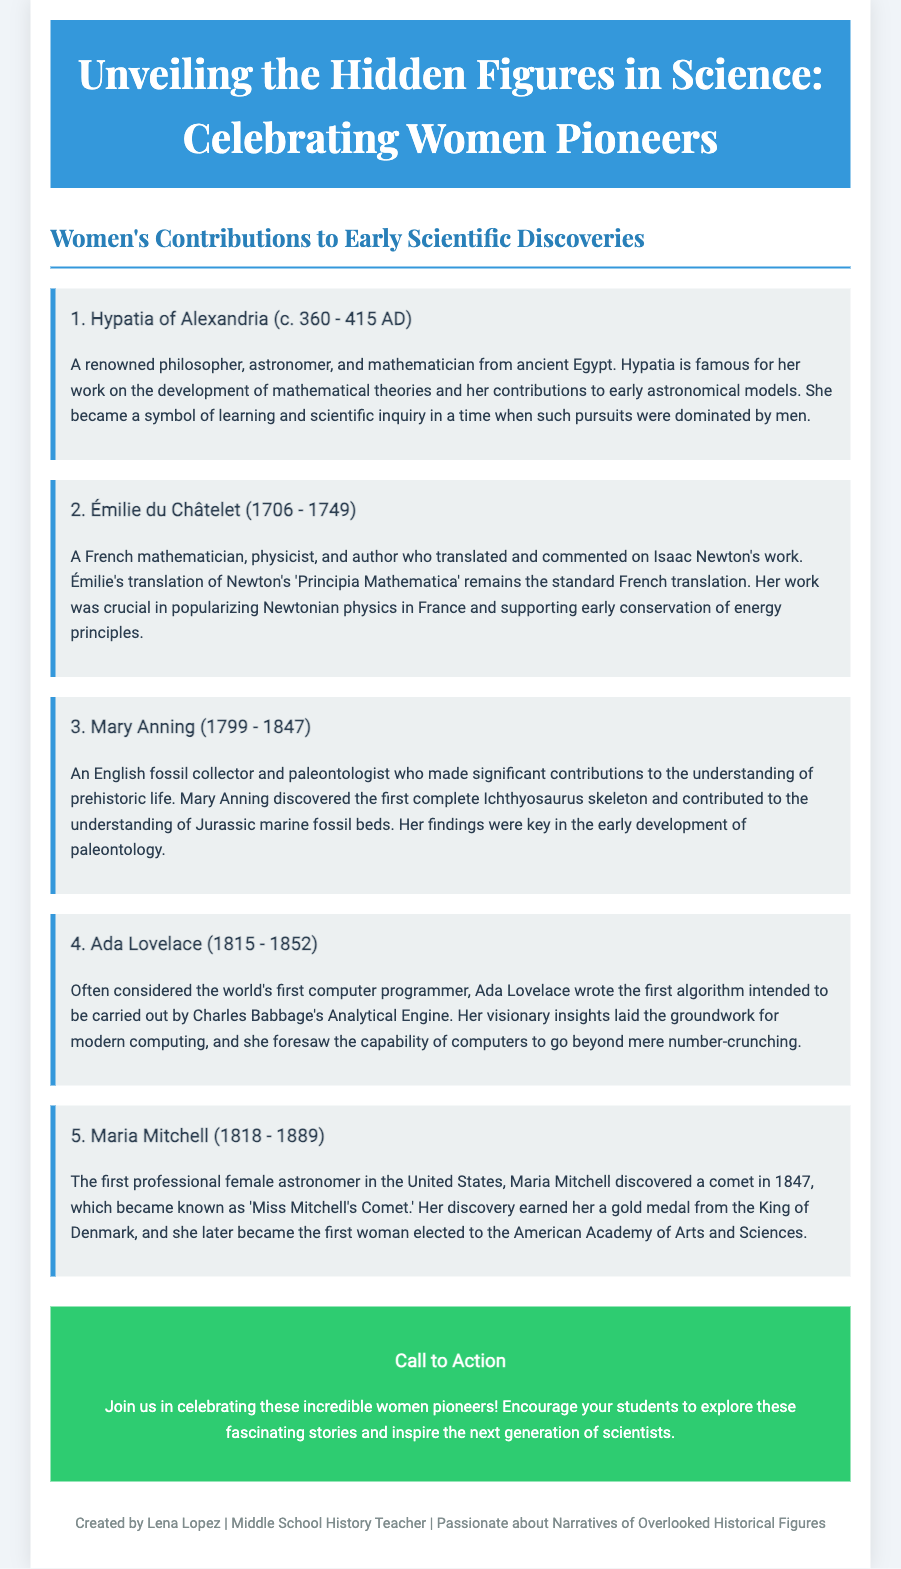What are the names of the first five female scientists featured? The document includes Hypatia of Alexandria, Émilie du Châtelet, Mary Anning, Ada Lovelace, and Maria Mitchell as the first five female scientists.
Answer: Hypatia of Alexandria, Émilie du Châtelet, Mary Anning, Ada Lovelace, Maria Mitchell What century was Hypatia of Alexandria active in? Hypatia of Alexandria lived during the 4th and early 5th centuries AD, specifically noted as c. 360 - 415 AD in the document.
Answer: 4th and 5th centuries Who translated Isaac Newton's work into French? The document states that Émilie du Châtelet translated and commented on Isaac Newton's work.
Answer: Émilie du Châtelet What significant discovery is Mary Anning known for? According to the document, Mary Anning is known for discovering the first complete Ichthyosaurus skeleton, contributing significantly to early paleontology.
Answer: Ichthyosaurus skeleton In what year did Maria Mitchell discover a comet? The document mentions that Maria Mitchell discovered a comet in 1847.
Answer: 1847 Which female scientist is considered the first computer programmer? The document identifies Ada Lovelace as often being considered the world's first computer programmer.
Answer: Ada Lovelace What is the call to action in the document? The call to action encourages readers to celebrate women pioneers and inspire students to explore their stories.
Answer: Celebrate these incredible women pioneers How many of the featured scientists have a connection to astronomy? The document highlights Hypatia of Alexandria, Mary Anning, and Maria Mitchell, indicating three scientists have a connection to astronomy.
Answer: Three 